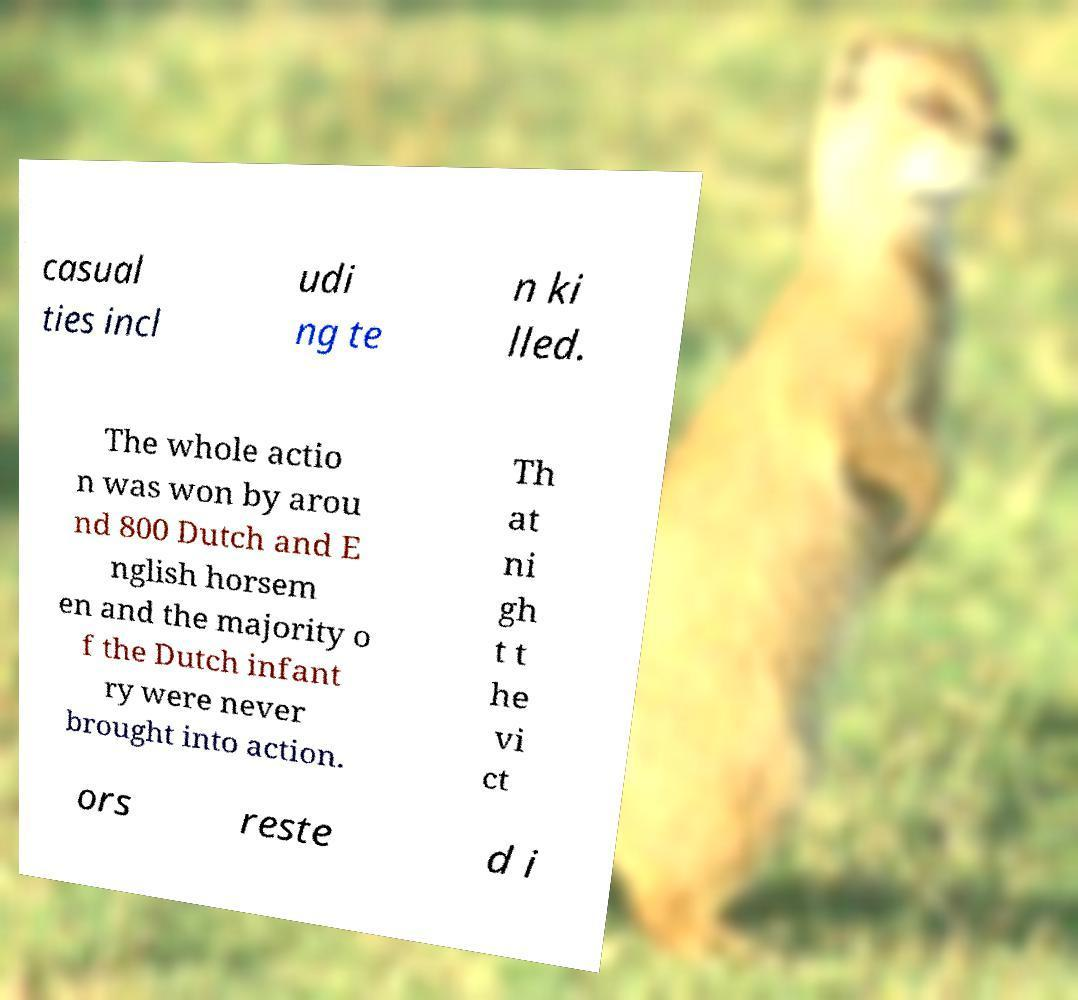Can you read and provide the text displayed in the image?This photo seems to have some interesting text. Can you extract and type it out for me? casual ties incl udi ng te n ki lled. The whole actio n was won by arou nd 800 Dutch and E nglish horsem en and the majority o f the Dutch infant ry were never brought into action. Th at ni gh t t he vi ct ors reste d i 